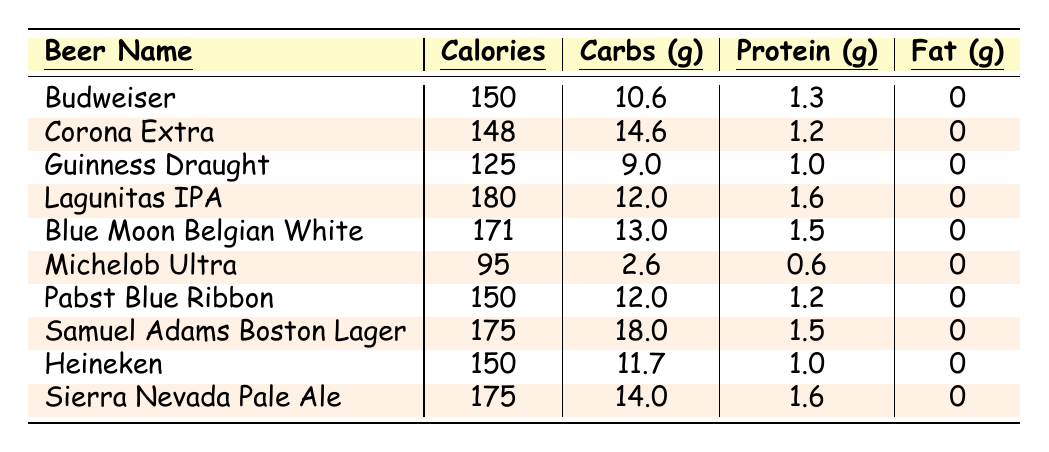What's the total calorie count for Budweiser? The table shows that Budweiser has 150 calories per 12oz.
Answer: 150 Which beer has the highest protein content? Reviewing the table, Lagunitas IPA has the highest protein content at 1.6 grams per 12oz.
Answer: Lagunitas IPA What is the average calorie count of the beers listed? To find the average, add all the calorie counts: (150 + 148 + 125 + 180 + 171 + 95 + 150 + 175 + 150 + 175) = 1,475. There are 10 beers, so the average is 1,475 / 10 = 147.5.
Answer: 147.5 Does Michelob Ultra have the fewest calories? Yes, Michelob Ultra has 95 calories, which is the least among all the beers in the table.
Answer: Yes How many grams of carbs does Samuel Adams Boston Lager contain compared to Guinness Draught? Samuel Adams Boston Lager has 18 grams of carbs, while Guinness Draught has 9 grams. The difference is 18 - 9 = 9 grams more for Samuel Adams.
Answer: 9 grams Are there any beers in the table that contain protein? Yes, all the beers listed do contain protein content, but Michelob Ultra has the least at 0.6 grams.
Answer: Yes What is the total amount of carbs in all the beers combined? The total carbs are calculated by summing the individual carb amounts: 10.6 + 14.6 + 9.0 + 12.0 + 13.0 + 2.6 + 12.0 + 18.0 + 11.7 + 14.0 =  8.0 grams.
Answer: 8.0 grams Which beers have the same calorie content? Both Budweiser and Pabst Blue Ribbon each have 150 calories per 12oz. This means they share the same value.
Answer: Budweiser and Pabst Blue Ribbon If I drink one of each beer, how many calories will I consume? The total calories would be 150 + 148 + 125 + 180 + 171 + 95 + 150 + 175 + 150 + 175 = 1,475.
Answer: 1,475 Which beer has the most calories but the least fat? Lagunitas IPA has 180 calories and 0 grams of fat, making it the beer with the most caloric content while containing no fat.
Answer: Lagunitas IPA 